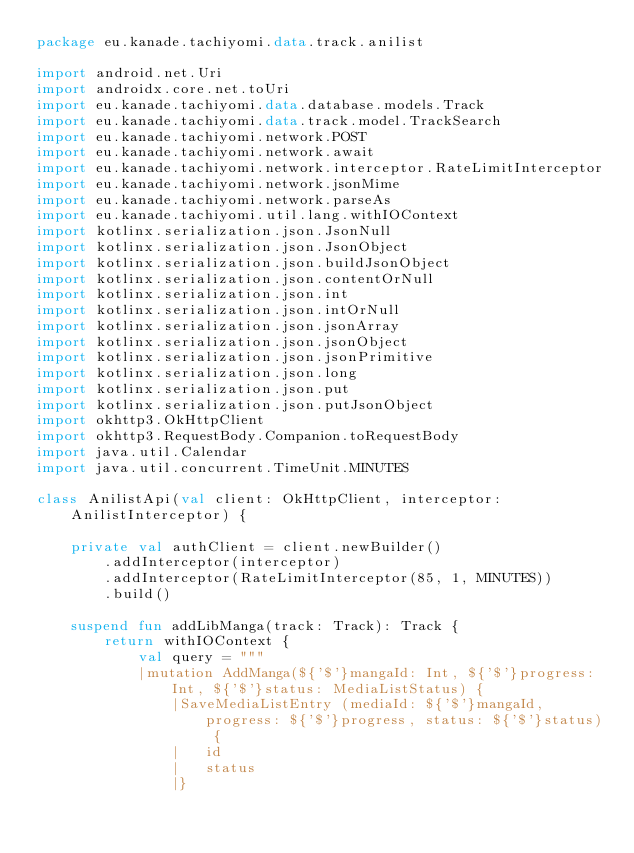<code> <loc_0><loc_0><loc_500><loc_500><_Kotlin_>package eu.kanade.tachiyomi.data.track.anilist

import android.net.Uri
import androidx.core.net.toUri
import eu.kanade.tachiyomi.data.database.models.Track
import eu.kanade.tachiyomi.data.track.model.TrackSearch
import eu.kanade.tachiyomi.network.POST
import eu.kanade.tachiyomi.network.await
import eu.kanade.tachiyomi.network.interceptor.RateLimitInterceptor
import eu.kanade.tachiyomi.network.jsonMime
import eu.kanade.tachiyomi.network.parseAs
import eu.kanade.tachiyomi.util.lang.withIOContext
import kotlinx.serialization.json.JsonNull
import kotlinx.serialization.json.JsonObject
import kotlinx.serialization.json.buildJsonObject
import kotlinx.serialization.json.contentOrNull
import kotlinx.serialization.json.int
import kotlinx.serialization.json.intOrNull
import kotlinx.serialization.json.jsonArray
import kotlinx.serialization.json.jsonObject
import kotlinx.serialization.json.jsonPrimitive
import kotlinx.serialization.json.long
import kotlinx.serialization.json.put
import kotlinx.serialization.json.putJsonObject
import okhttp3.OkHttpClient
import okhttp3.RequestBody.Companion.toRequestBody
import java.util.Calendar
import java.util.concurrent.TimeUnit.MINUTES

class AnilistApi(val client: OkHttpClient, interceptor: AnilistInterceptor) {

    private val authClient = client.newBuilder()
        .addInterceptor(interceptor)
        .addInterceptor(RateLimitInterceptor(85, 1, MINUTES))
        .build()

    suspend fun addLibManga(track: Track): Track {
        return withIOContext {
            val query = """
            |mutation AddManga(${'$'}mangaId: Int, ${'$'}progress: Int, ${'$'}status: MediaListStatus) {
                |SaveMediaListEntry (mediaId: ${'$'}mangaId, progress: ${'$'}progress, status: ${'$'}status) { 
                |   id 
                |   status 
                |} </code> 